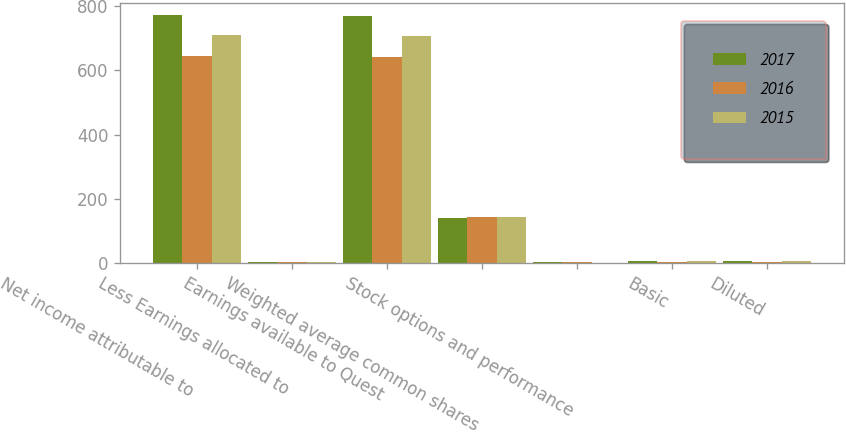Convert chart. <chart><loc_0><loc_0><loc_500><loc_500><stacked_bar_chart><ecel><fcel>Net income attributable to<fcel>Less Earnings allocated to<fcel>Earnings available to Quest<fcel>Weighted average common shares<fcel>Stock options and performance<fcel>Basic<fcel>Diluted<nl><fcel>2017<fcel>772<fcel>3<fcel>769<fcel>140<fcel>3<fcel>5.63<fcel>5.5<nl><fcel>2016<fcel>645<fcel>3<fcel>642<fcel>142<fcel>2<fcel>4.58<fcel>4.51<nl><fcel>2015<fcel>709<fcel>3<fcel>706<fcel>145<fcel>1<fcel>4.92<fcel>4.87<nl></chart> 